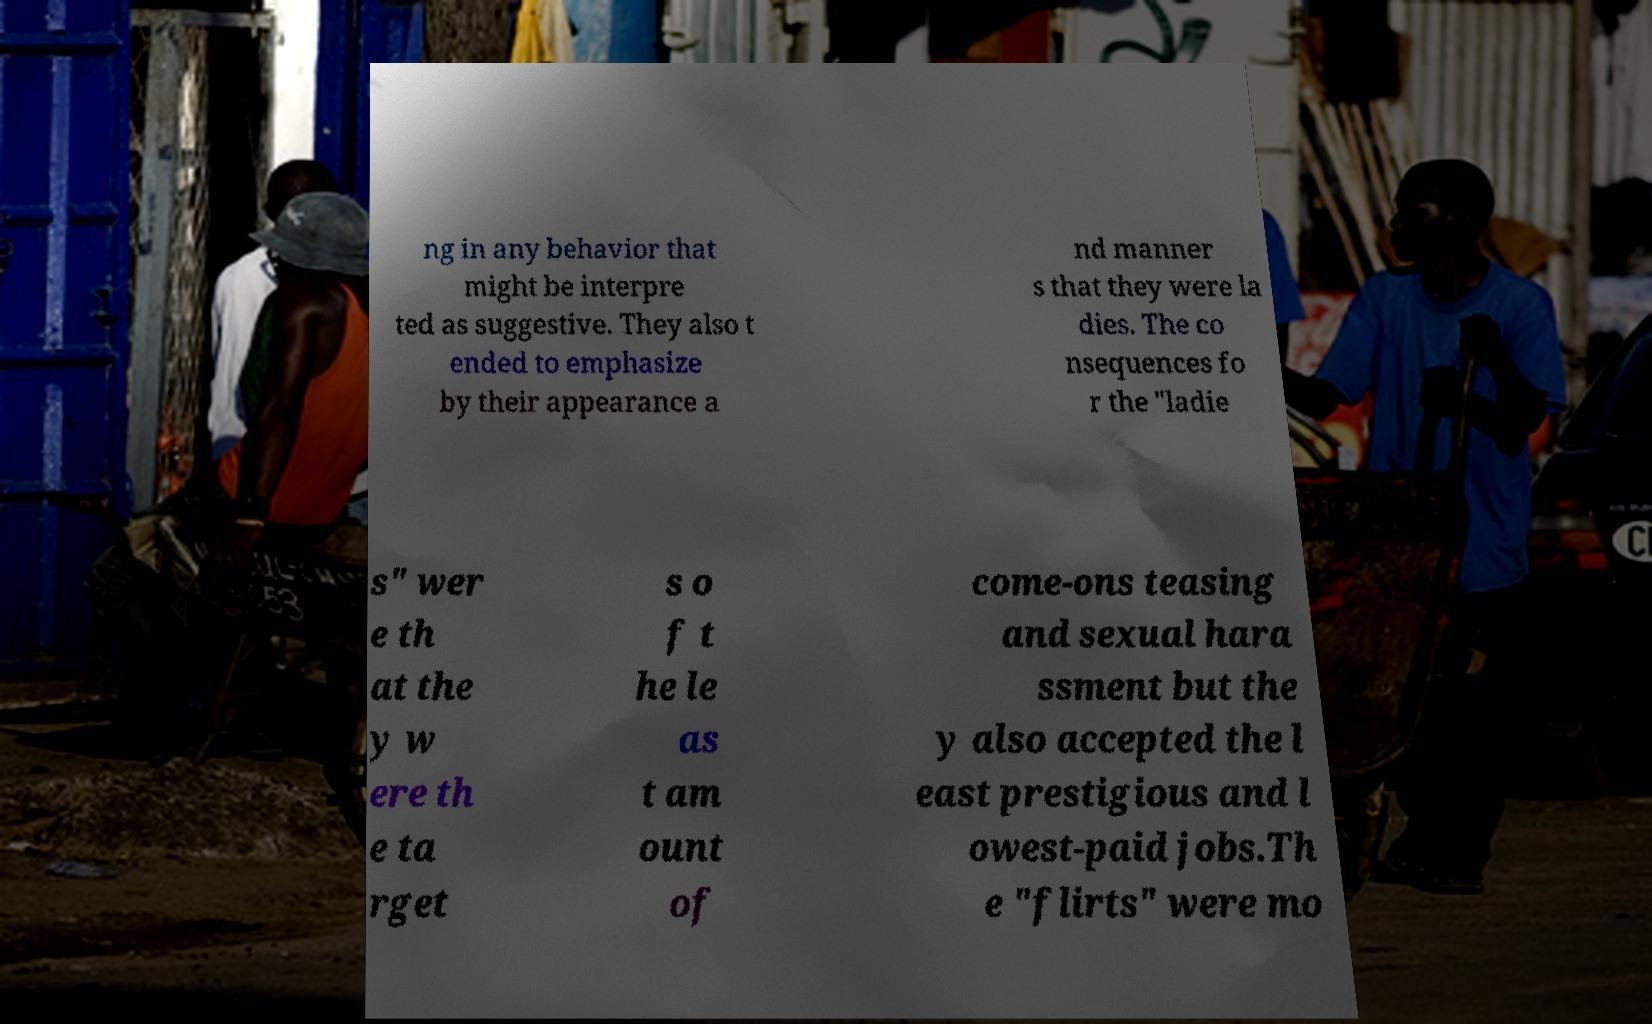Can you read and provide the text displayed in the image?This photo seems to have some interesting text. Can you extract and type it out for me? ng in any behavior that might be interpre ted as suggestive. They also t ended to emphasize by their appearance a nd manner s that they were la dies. The co nsequences fo r the "ladie s" wer e th at the y w ere th e ta rget s o f t he le as t am ount of come-ons teasing and sexual hara ssment but the y also accepted the l east prestigious and l owest-paid jobs.Th e "flirts" were mo 